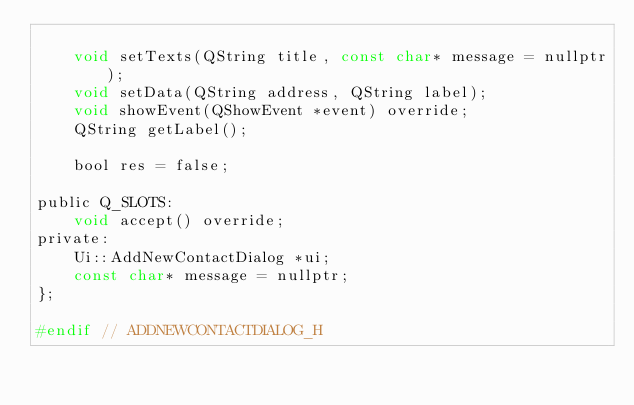<code> <loc_0><loc_0><loc_500><loc_500><_C_>
    void setTexts(QString title, const char* message = nullptr);
    void setData(QString address, QString label);
    void showEvent(QShowEvent *event) override;
    QString getLabel();

    bool res = false;

public Q_SLOTS:
    void accept() override;
private:
    Ui::AddNewContactDialog *ui;
    const char* message = nullptr;
};

#endif // ADDNEWCONTACTDIALOG_H
</code> 